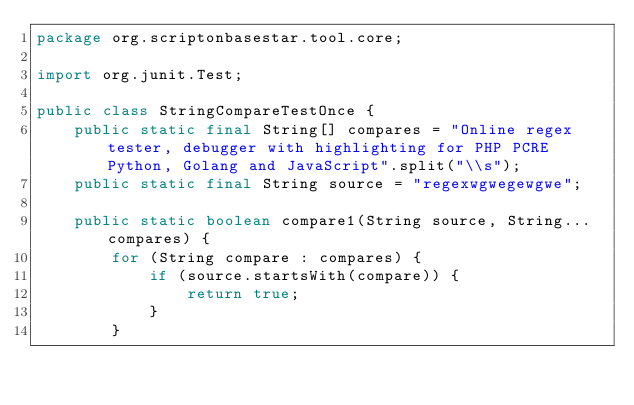Convert code to text. <code><loc_0><loc_0><loc_500><loc_500><_Java_>package org.scriptonbasestar.tool.core;

import org.junit.Test;

public class StringCompareTestOnce {
	public static final String[] compares = "Online regex tester, debugger with highlighting for PHP PCRE Python, Golang and JavaScript".split("\\s");
	public static final String source = "regexwgwegewgwe";

	public static boolean compare1(String source, String... compares) {
		for (String compare : compares) {
			if (source.startsWith(compare)) {
				return true;
			}
		}</code> 